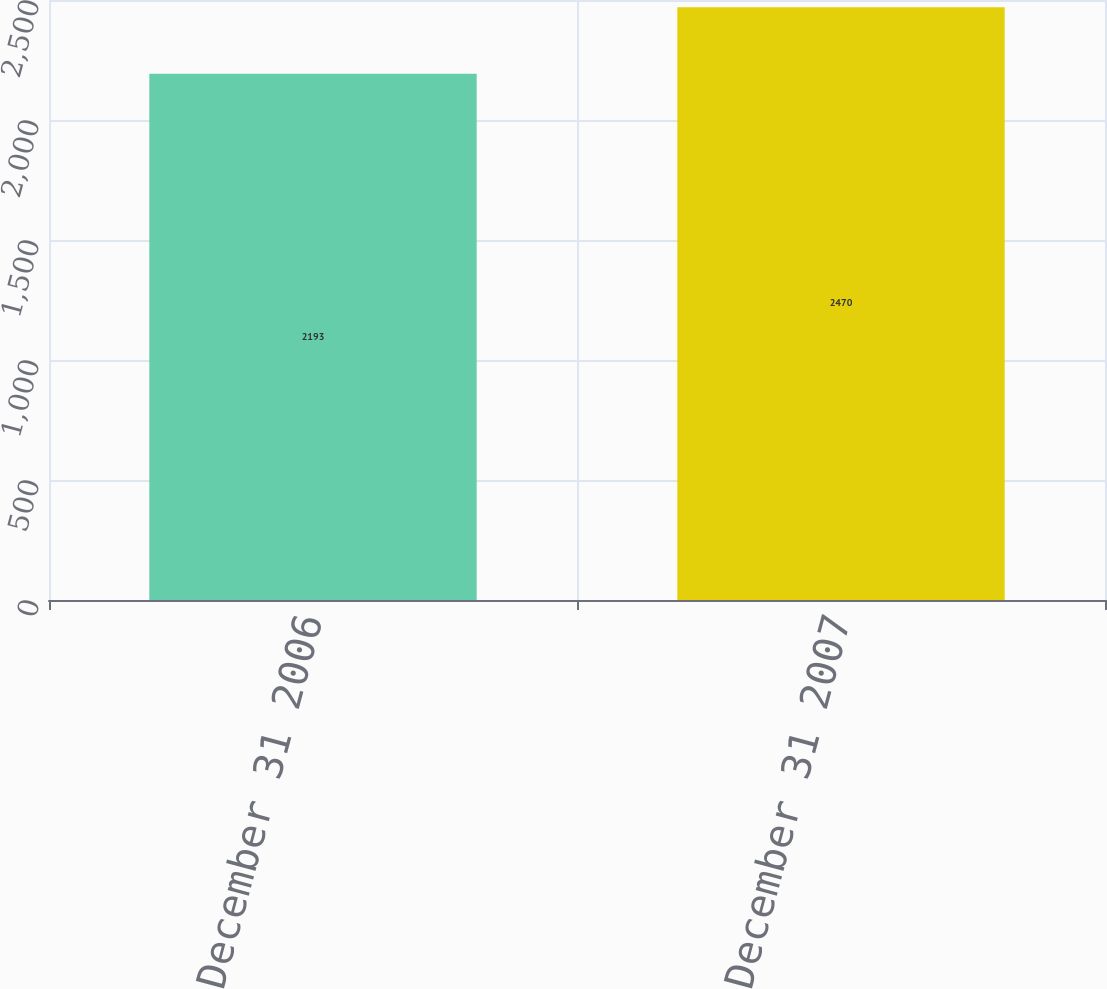Convert chart to OTSL. <chart><loc_0><loc_0><loc_500><loc_500><bar_chart><fcel>Balance as of December 31 2006<fcel>Balance as of December 31 2007<nl><fcel>2193<fcel>2470<nl></chart> 